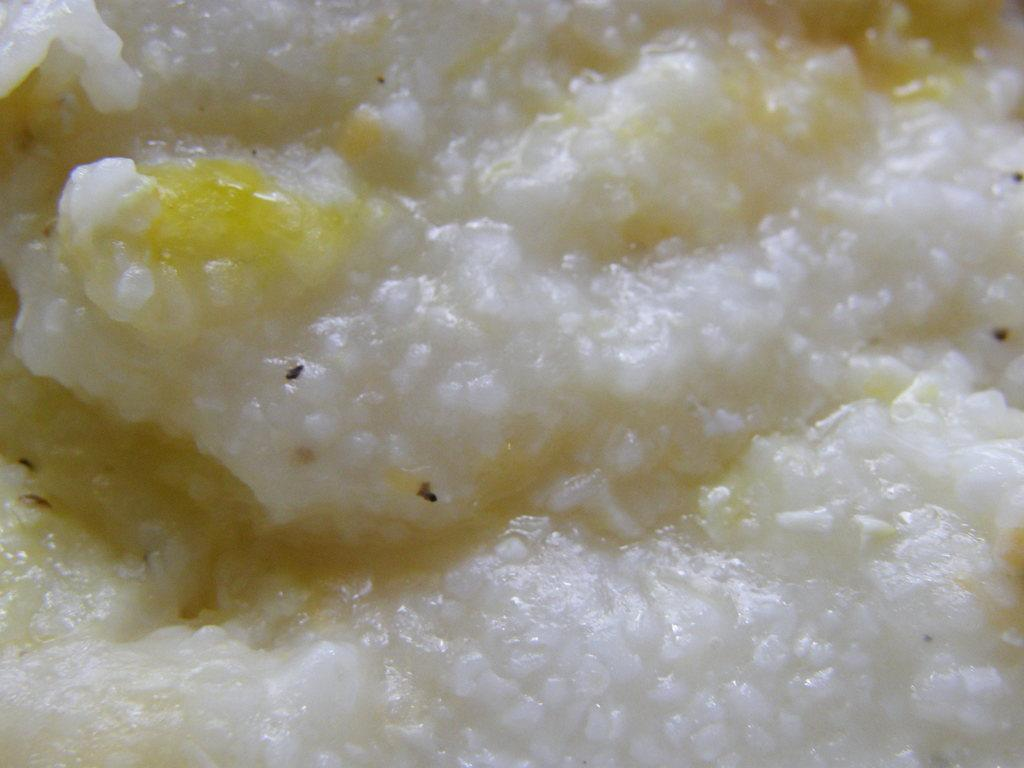What type of food item is visible in the image? There is a food item in the image, but its specific type cannot be determined from the provided facts. Can you describe the color of the food item? The food item is white and yellow in color. How does the cream drain from the example in the image? There is no cream or example present in the image, so this question cannot be answered. 